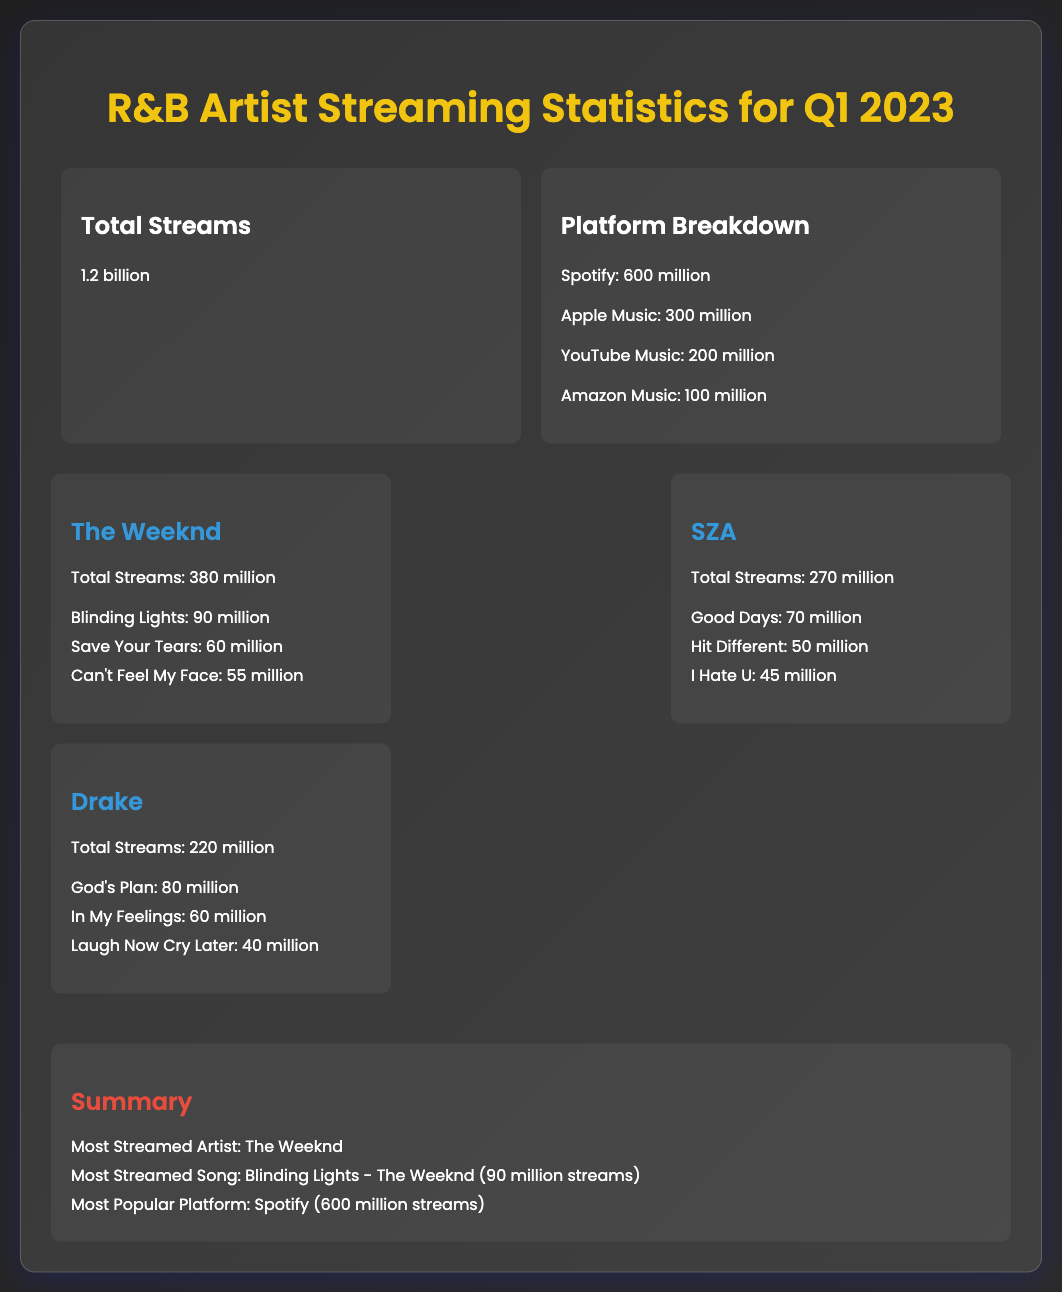What is the total number of streams? The total streams are presented in the overview section of the document, listed as 1.2 billion.
Answer: 1.2 billion Who is the most streamed artist? The summary section highlights the most streamed artist, which is The Weeknd.
Answer: The Weeknd According to the platform breakdown, how many streams did Spotify have? The platform breakdown details Spotify's streams as listed in the document, which is 600 million.
Answer: 600 million What is the most streamed song? The summary specifies the most streamed song as Blinding Lights with 90 million streams.
Answer: Blinding Lights How many streams did SZA achieve in total? The artist card for SZA provides her total streams, which amount to 270 million.
Answer: 270 million Which platform is the most popular according to the document? The summary mentions the most popular platform as Spotify with the highest number of streams.
Answer: Spotify What was the total number of streams for Drake? The artist card for Drake indicates his total streams as 220 million.
Answer: 220 million How many streams did "Good Days" by SZA receive? The song list under SZA's section shows "Good Days" had 70 million streams.
Answer: 70 million How many streams did Amazon Music account for in the breakdown? The platform breakdown specifies that Amazon Music had 100 million streams.
Answer: 100 million 